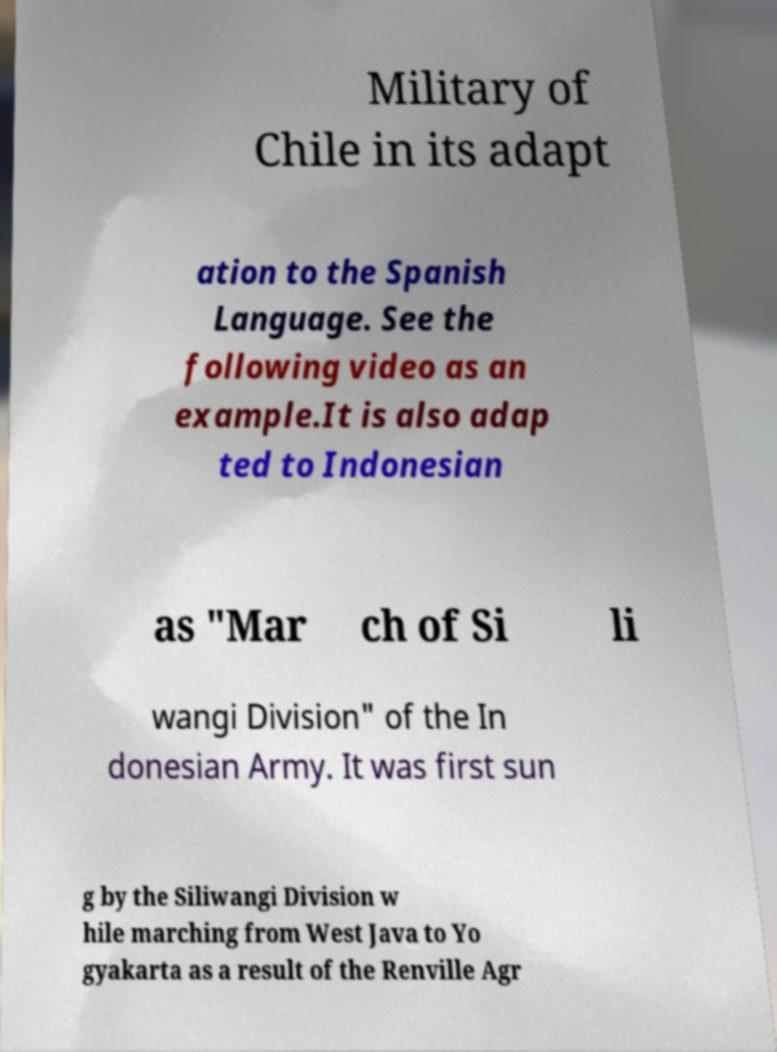For documentation purposes, I need the text within this image transcribed. Could you provide that? Military of Chile in its adapt ation to the Spanish Language. See the following video as an example.It is also adap ted to Indonesian as "Mar ch of Si li wangi Division" of the In donesian Army. It was first sun g by the Siliwangi Division w hile marching from West Java to Yo gyakarta as a result of the Renville Agr 